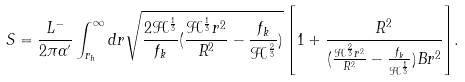<formula> <loc_0><loc_0><loc_500><loc_500>S = \frac { L ^ { - } } { 2 \pi \alpha ^ { \prime } } \int _ { r _ { h } } ^ { \infty } { d r \sqrt { \frac { 2 \mathcal { H } ^ { \frac { 1 } { 3 } } } { f _ { k } } ( \frac { \mathcal { H } ^ { \frac { 1 } { 3 } } r ^ { 2 } } { R ^ { 2 } } - \frac { f _ { k } } { \mathcal { H } ^ { \frac { 2 } { 3 } } } ) } \left [ 1 + \frac { R ^ { 2 } } { ( \frac { \mathcal { H } ^ { \frac { 2 } { 3 } } r ^ { 2 } } { R ^ { 2 } } - \frac { f _ { k } } { \mathcal { H } ^ { \frac { 1 } { 3 } } } ) B r ^ { 2 } } \right ] } .</formula> 